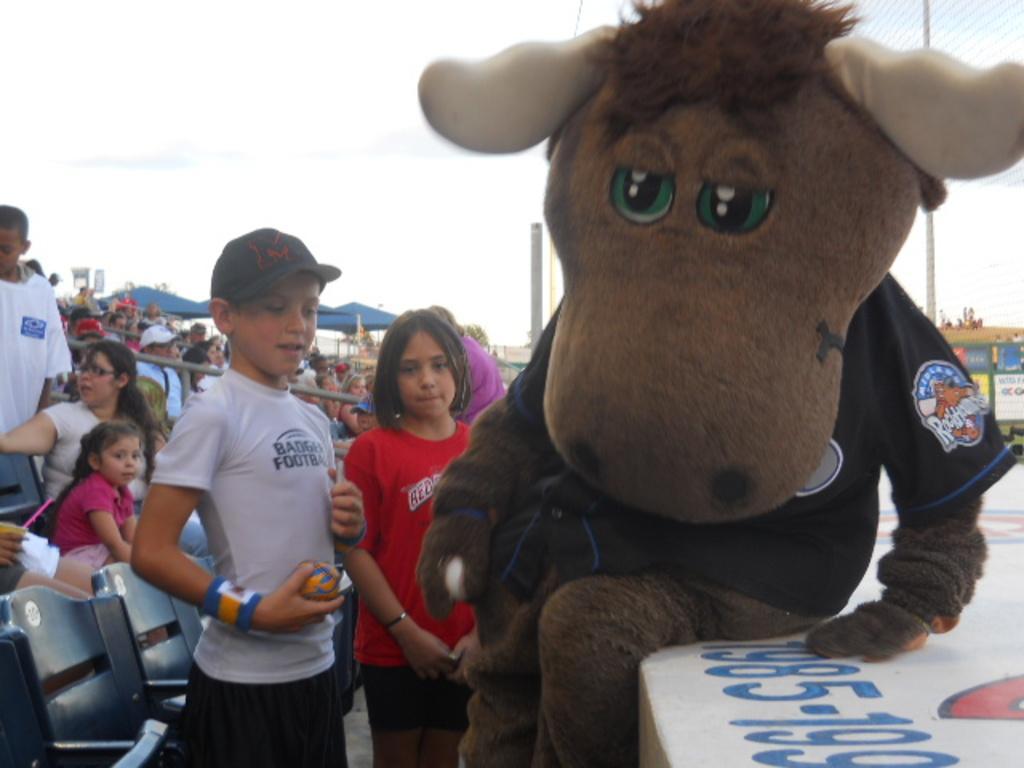How would you summarize this image in a sentence or two? In this image we can see a person in a different costume sitting here and these two children are standing here. In the background, we can see chairs and people sitting on it, tents, poles and the sky. 